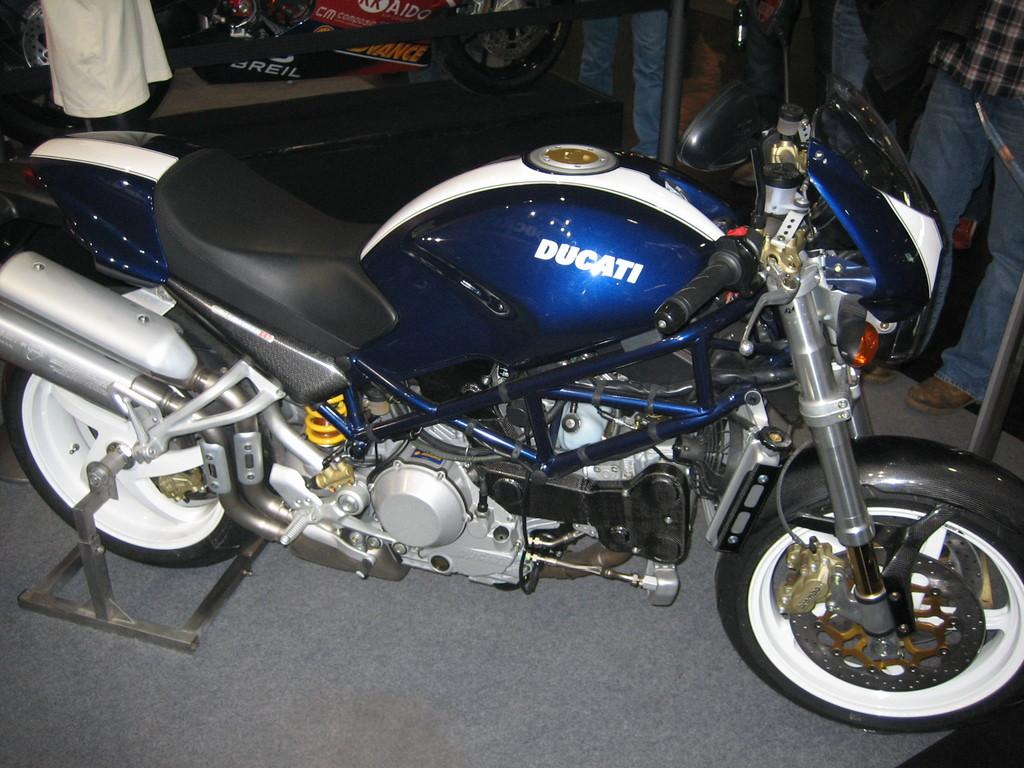What object is placed on the floor in the image? There is a vehicle on the floor in the image. What can be seen at the top of the image? People are visible at the top of the image, along with a barrier and a bike. What might be used to prevent access or movement in the image? The barrier at the top of the image might be used to prevent access or movement. What type of eggnog is being served at the event in the image? There is no event or eggnog present in the image; it features a vehicle on the floor and a scene at the top of the image. How does the volleyball game affect the people in the image? There is no volleyball game present in the image; it features a vehicle on the floor and a scene at the top of the image. --- Facts: 1. There is a person holding a book in the image. 2. The book has a blue cover. 3. The person is sitting on a chair. 4. There is a table next to the chair. 5. A lamp is present on the table. Absurd Topics: parrot, sandcastle, fireworks Conversation: What is the person in the image holding? The person in the image is holding a book. What color is the book's cover? The book has a blue cover. What is the person sitting on in the image? The person is sitting on a chair. What object is present on the table next to the chair? A lamp is present on the table. Reasoning: Let's think step by step in order to produce the conversation. We start by identifying the main subject in the image, which is the person holding a book. Then, we describe the book's cover color and the person's seating arrangement. Finally, we mention the presence of a lamp on the table next to the chair. Each question is designed to elicit a specific detail about the image that is known from the provided facts. Absurd Question/Answer: Can you tell me how many parrots are sitting on the person's shoulder in the image? There are no parrots present in the image; it features a person holding a book with a blue cover, sitting on a chair, and a lamp on the table. What type of fireworks display can be seen in the background of the image? There is no fireworks display present in the image; it features a person holding a book with a blue cover, sitting on a chair, and a lamp on the table. 